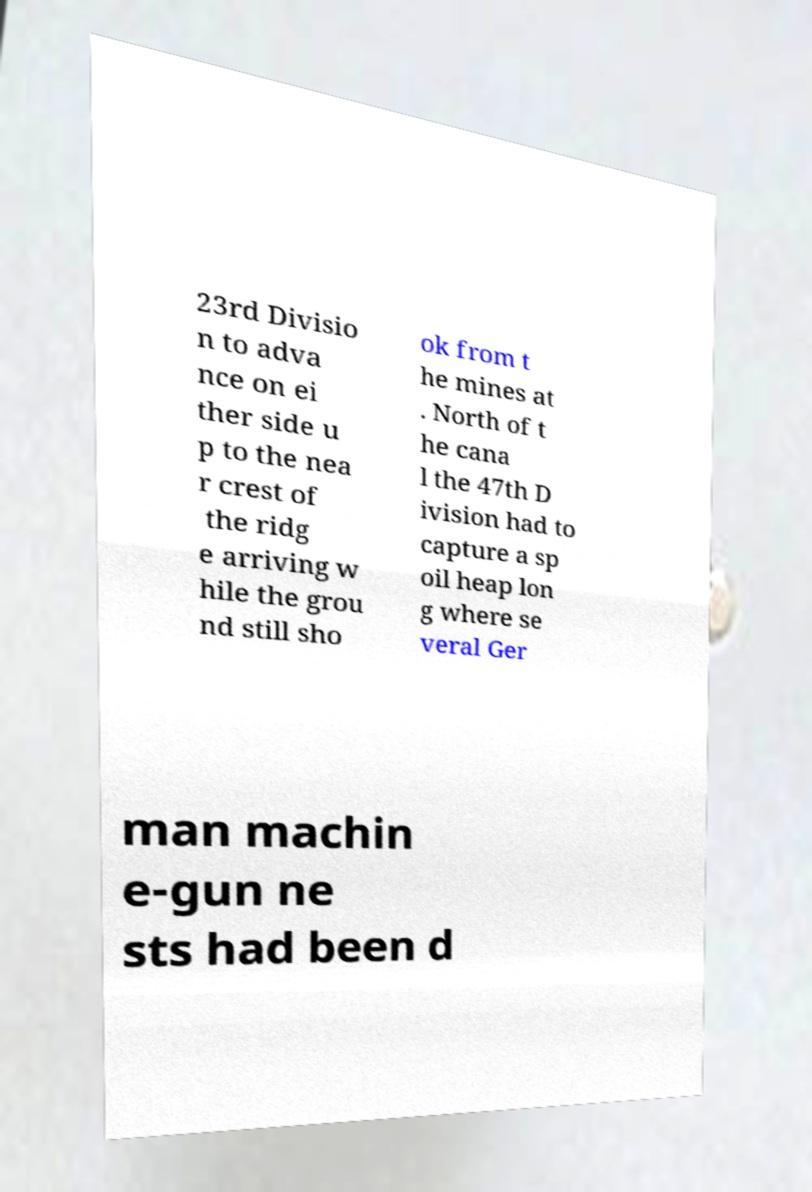Can you read and provide the text displayed in the image?This photo seems to have some interesting text. Can you extract and type it out for me? 23rd Divisio n to adva nce on ei ther side u p to the nea r crest of the ridg e arriving w hile the grou nd still sho ok from t he mines at . North of t he cana l the 47th D ivision had to capture a sp oil heap lon g where se veral Ger man machin e-gun ne sts had been d 